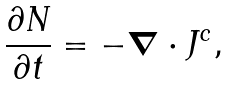Convert formula to latex. <formula><loc_0><loc_0><loc_500><loc_500>\frac { \partial N } { \partial t } = - { \boldsymbol \nabla } \cdot { J } ^ { c } ,</formula> 